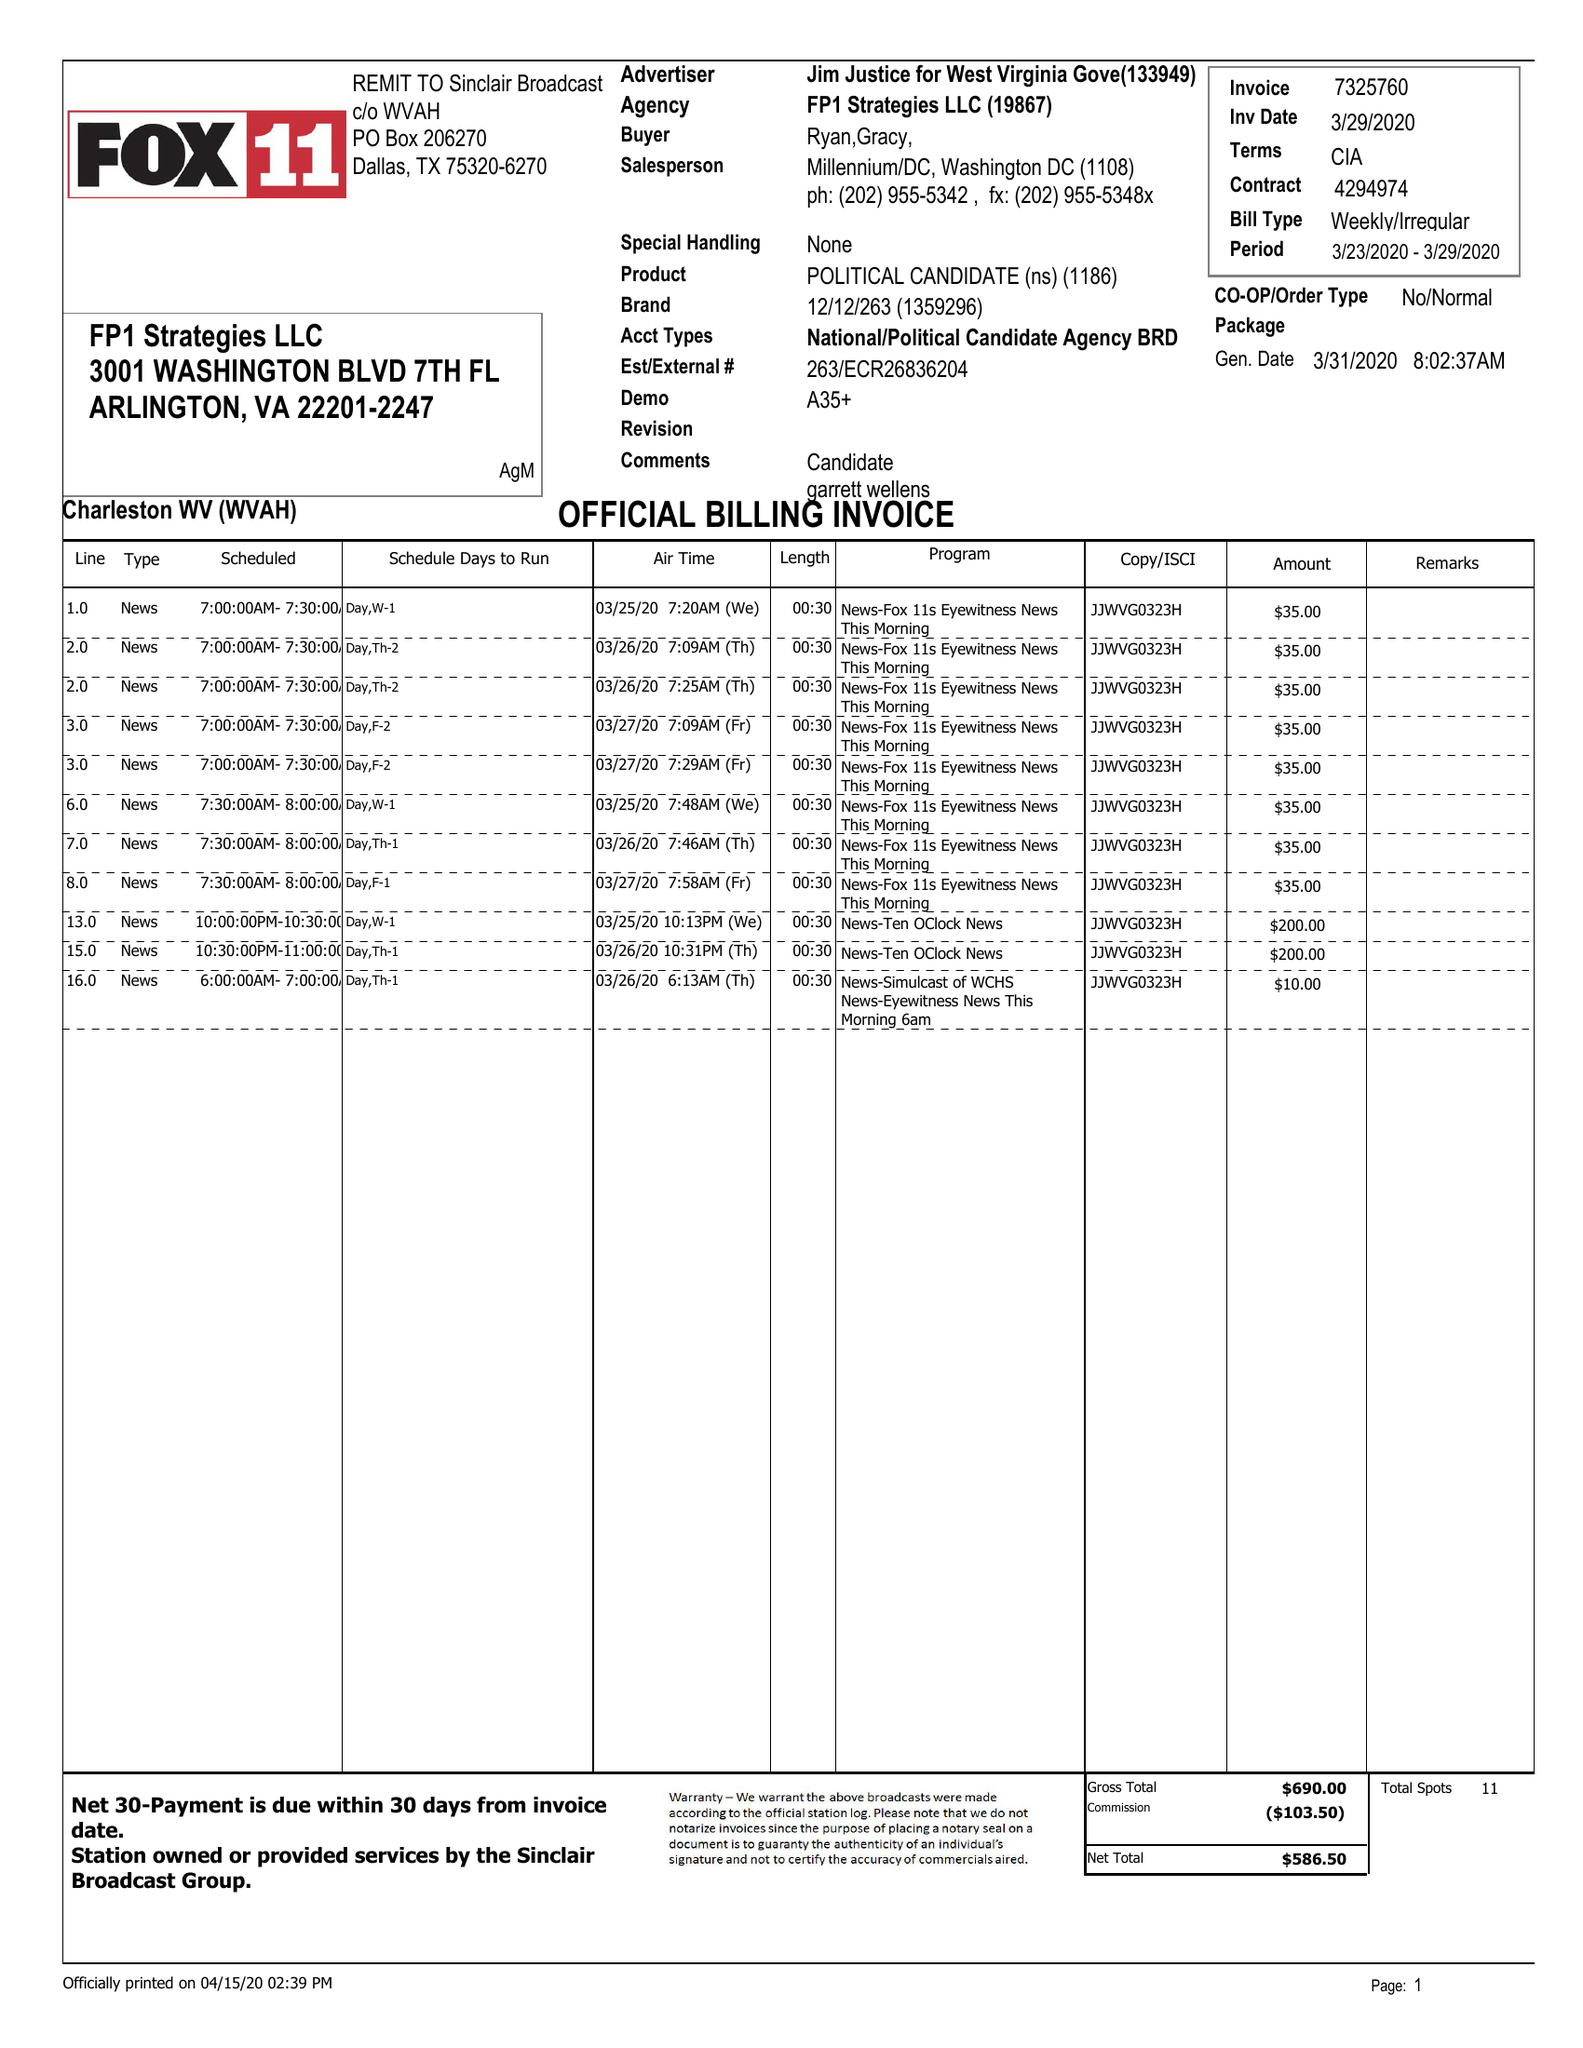What is the value for the gross_amount?
Answer the question using a single word or phrase. 690.00 